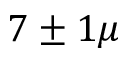<formula> <loc_0><loc_0><loc_500><loc_500>7 \pm 1 \mu</formula> 